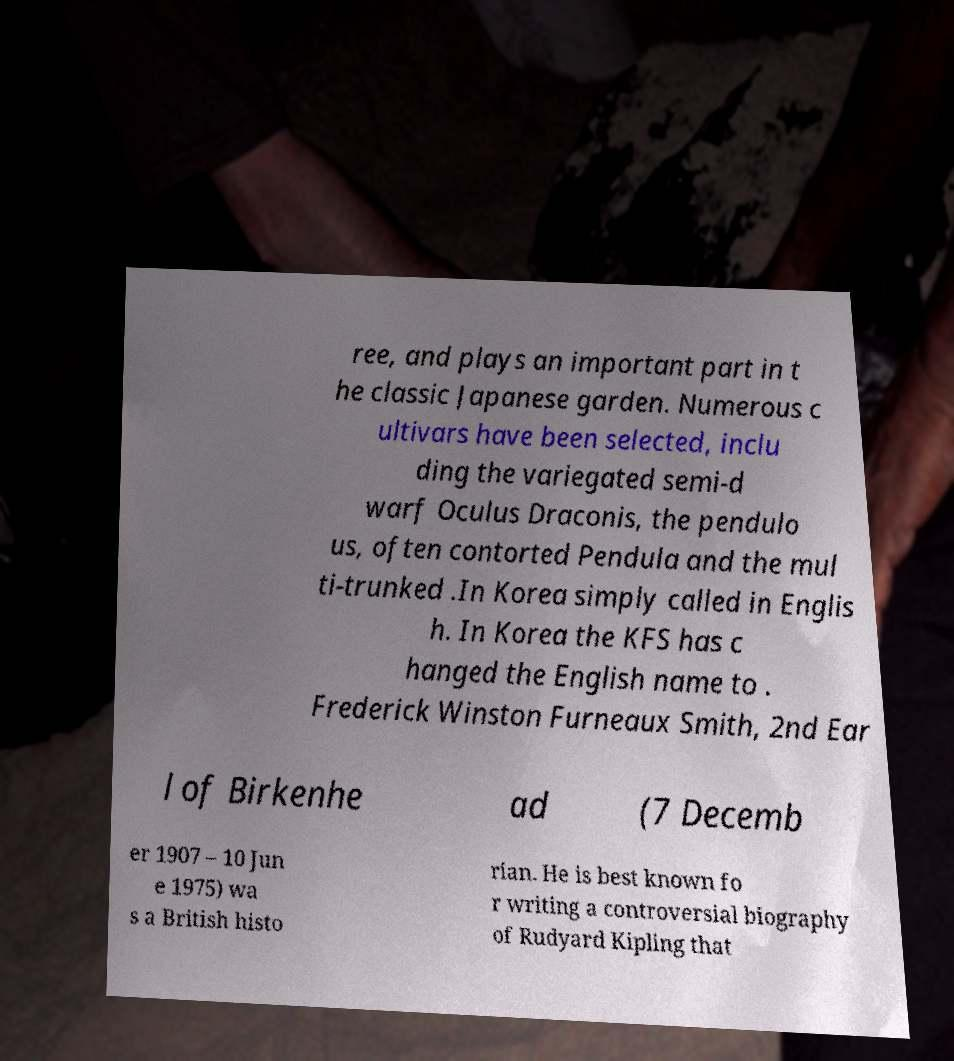Can you accurately transcribe the text from the provided image for me? ree, and plays an important part in t he classic Japanese garden. Numerous c ultivars have been selected, inclu ding the variegated semi-d warf Oculus Draconis, the pendulo us, often contorted Pendula and the mul ti-trunked .In Korea simply called in Englis h. In Korea the KFS has c hanged the English name to . Frederick Winston Furneaux Smith, 2nd Ear l of Birkenhe ad (7 Decemb er 1907 – 10 Jun e 1975) wa s a British histo rian. He is best known fo r writing a controversial biography of Rudyard Kipling that 